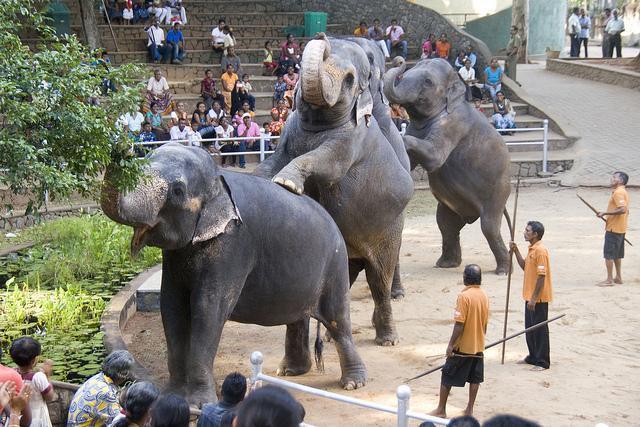How many people are in the photo?
Give a very brief answer. 6. How many elephants are there?
Give a very brief answer. 4. 